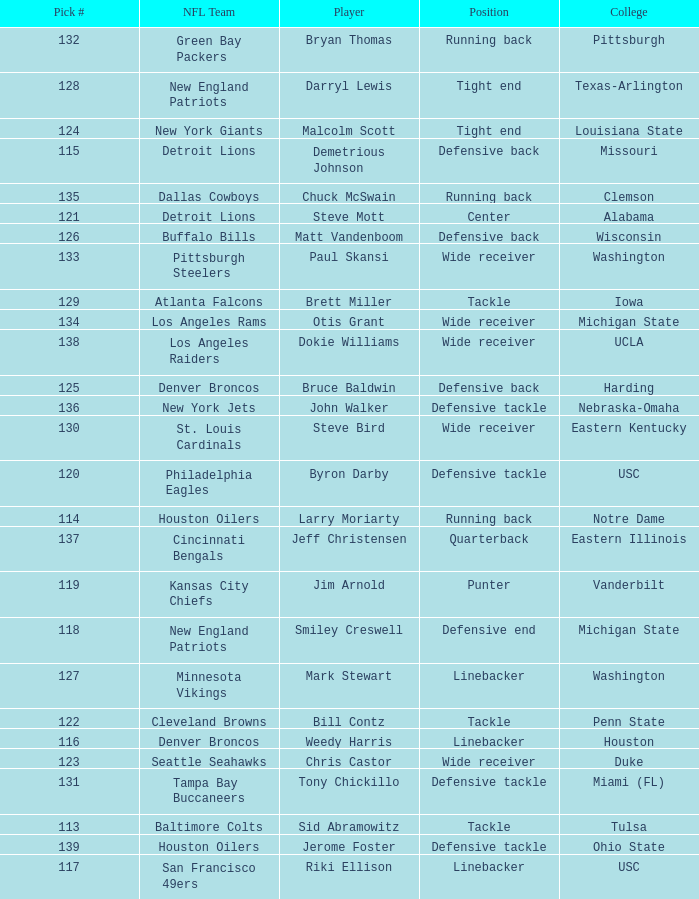Which player did the green bay packers pick? Bryan Thomas. 